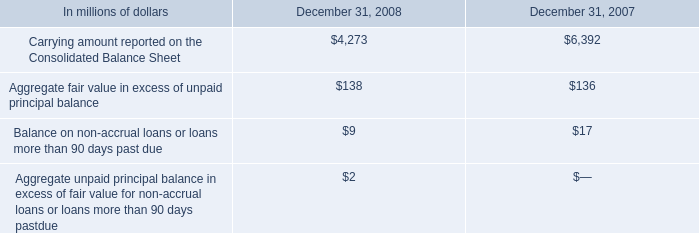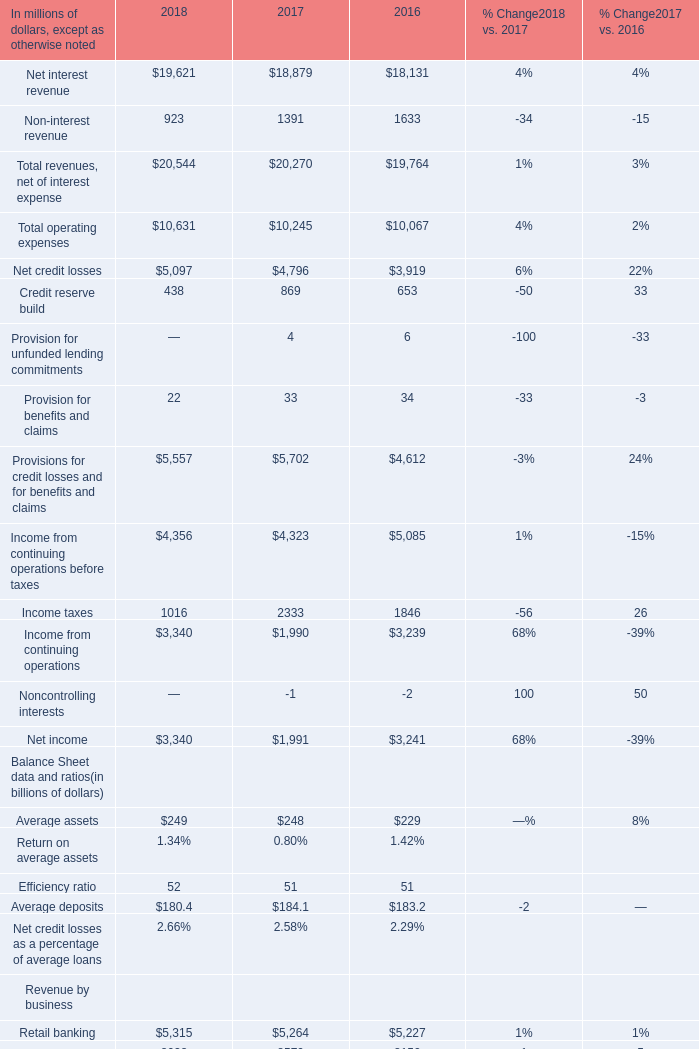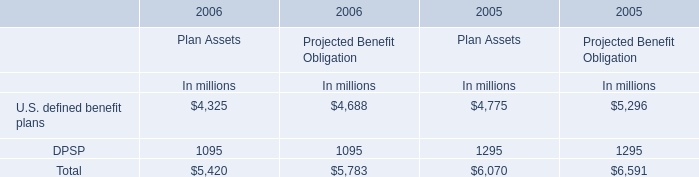What is the total amount of U.S. defined benefit plans of 2006 Plan Assets In millions, and Income from continuing operations before taxes of 2018 ? 
Computations: (4325.0 + 4356.0)
Answer: 8681.0. 